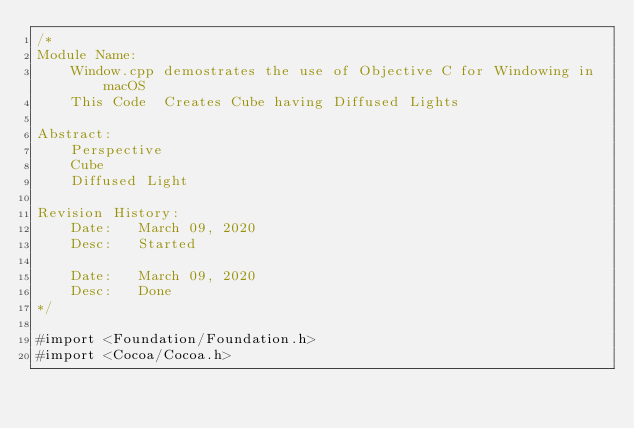<code> <loc_0><loc_0><loc_500><loc_500><_ObjectiveC_>/*
Module Name:
    Window.cpp demostrates the use of Objective C for Windowing in macOS
    This Code  Creates Cube having Diffused Lights

Abstract:
    Perspective
    Cube
    Diffused Light

Revision History:
    Date:   March 09, 2020
    Desc:   Started

    Date:   March 09, 2020
    Desc:   Done
*/

#import <Foundation/Foundation.h>
#import <Cocoa/Cocoa.h></code> 